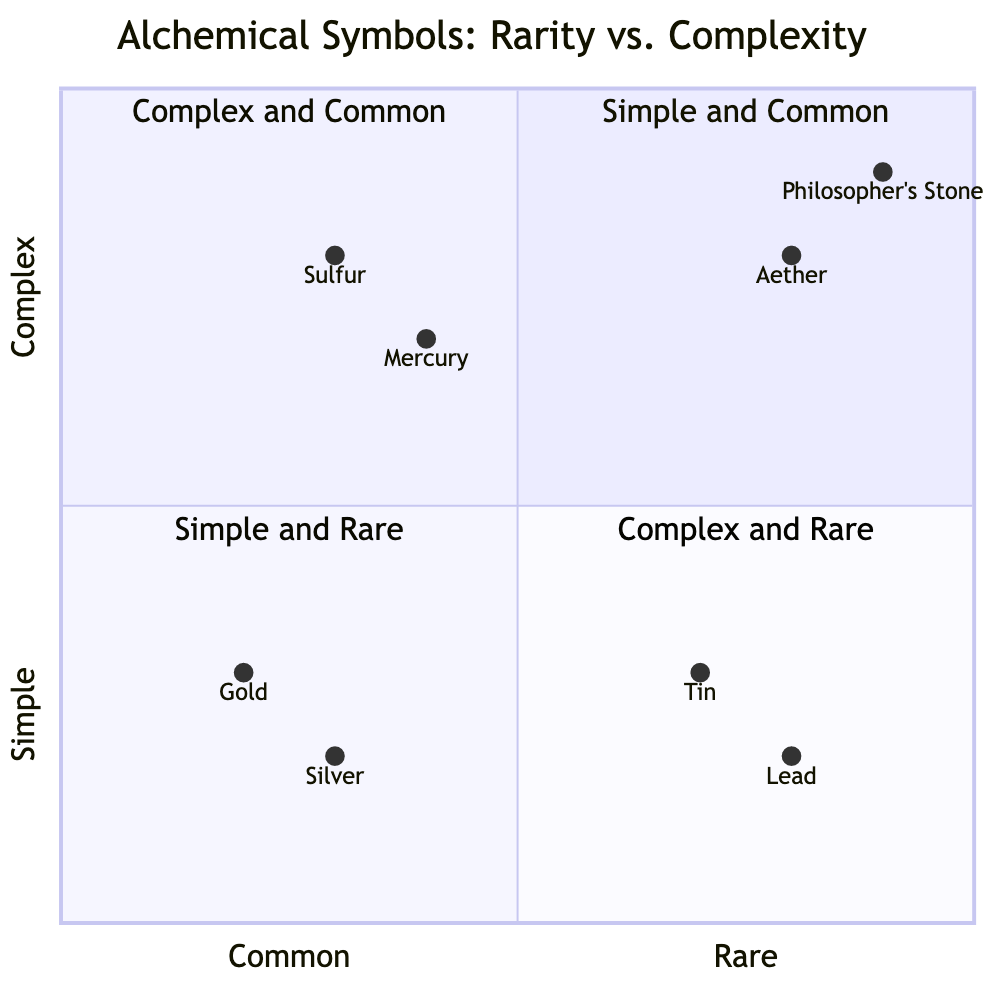What symbols are located in the Complex and Common quadrant? The Complex and Common quadrant contains symbols for Mercury and Sulfur. This can be determined by checking the quadrant labeled "Complex and Common" on the diagram, where these two symbols are plotted.
Answer: Mercury and Sulfur Which symbol is associated with the Simple and Rare quadrant? The Simple and Rare quadrant includes symbols for Tin and Lead. Observing the quadrant labeled "Simple and Rare," we can identify both symbols positioned within that area.
Answer: Tin and Lead How many symbols are in the Complex and Rare quadrant? There are two symbols in the Complex and Rare quadrant: the Philosopher’s Stone and Aether. Counting each symbol in the quadrant labeled "Complex and Rare" gives us the total.
Answer: 2 Which symbol is at coordinates [0.9, 0.9]? The symbol located at coordinates [0.9, 0.9] is the Philosopher's Stone. By analyzing the x and y values plotted in the quadrant, we see that this specific symbol is represented at those coordinates.
Answer: Philosopher's Stone What is the visual representation of the symbol for Gold? The symbol for Gold is a simple circle with a dot in the center, which is a key feature described in the data. Referring to the description provided for Gold, we can identify its visual representation.
Answer: Circle with a dot Which two symbols share the same complexity level but different rarity in this diagram? Mercury and Sulfur both share a complex design but differ in their rarity, as they are both located in the complex and common quadrant. This is derived from examining their positions on the diagram.
Answer: Mercury and Sulfur How does the symbol for Aether compare in complexity to that of Gold? The symbol for Aether is considered complex, while the symbol for Gold is simple. This inference is drawn from the placement in their respective quadrants on the diagram, where Aether is positioned in the Complex and Rare quadrant and Gold in the Simple and Common quadrant.
Answer: Complex vs Simple Which quadrant features the symbol for Silver? The symbol for Silver is located in the Simple and Common quadrant. Checking the placement of Silver corresponds with its designation in that specific quadrant on the diagram.
Answer: Simple and Common 